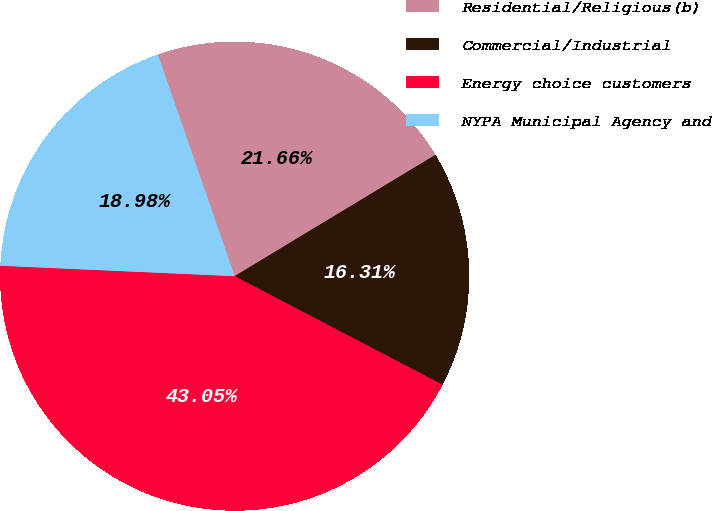Convert chart to OTSL. <chart><loc_0><loc_0><loc_500><loc_500><pie_chart><fcel>Residential/Religious(b)<fcel>Commercial/Industrial<fcel>Energy choice customers<fcel>NYPA Municipal Agency and<nl><fcel>21.66%<fcel>16.31%<fcel>43.05%<fcel>18.98%<nl></chart> 